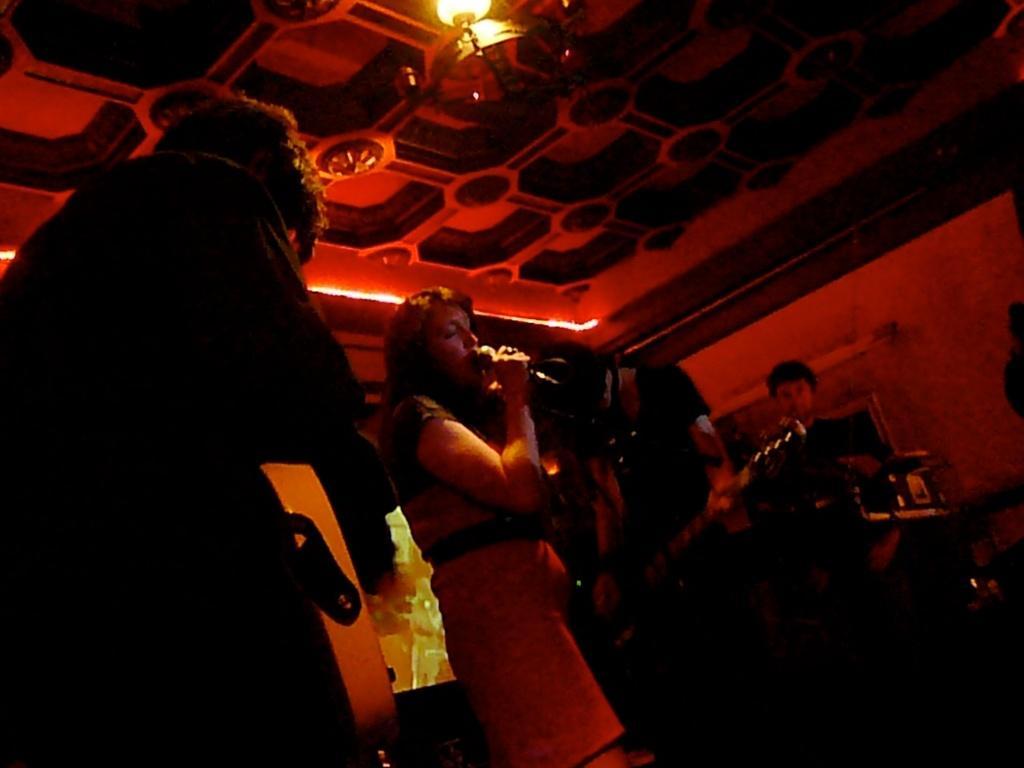In one or two sentences, can you explain what this image depicts? In this image I see 4 persons in which this person is holding a mic and this man is holding a guitar in his hands and I see the wall and I see the lights on the ceiling. 